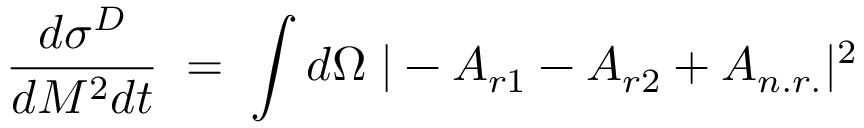<formula> <loc_0><loc_0><loc_500><loc_500>\frac { d \sigma ^ { D } } { d M ^ { 2 } d t } \, = \, \int d \Omega \, | - A _ { r 1 } - A _ { r 2 } + A _ { n . r . } | ^ { 2 } \,</formula> 